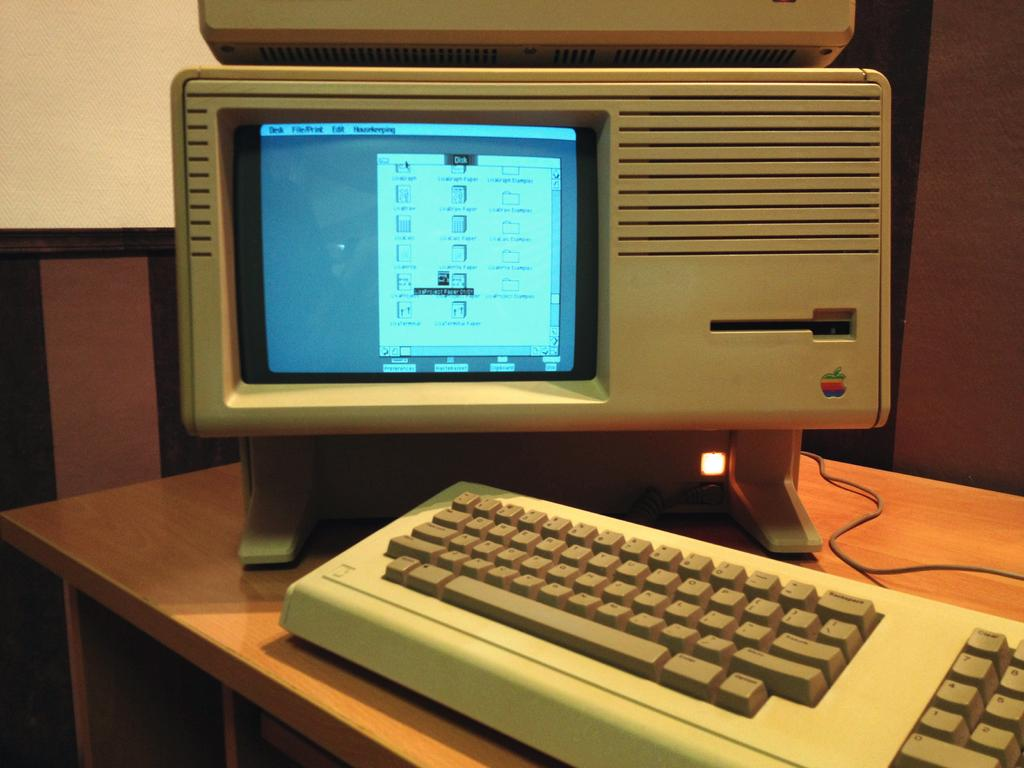Provide a one-sentence caption for the provided image. An old computer displays a window on the monitor that is titled "disk.". 